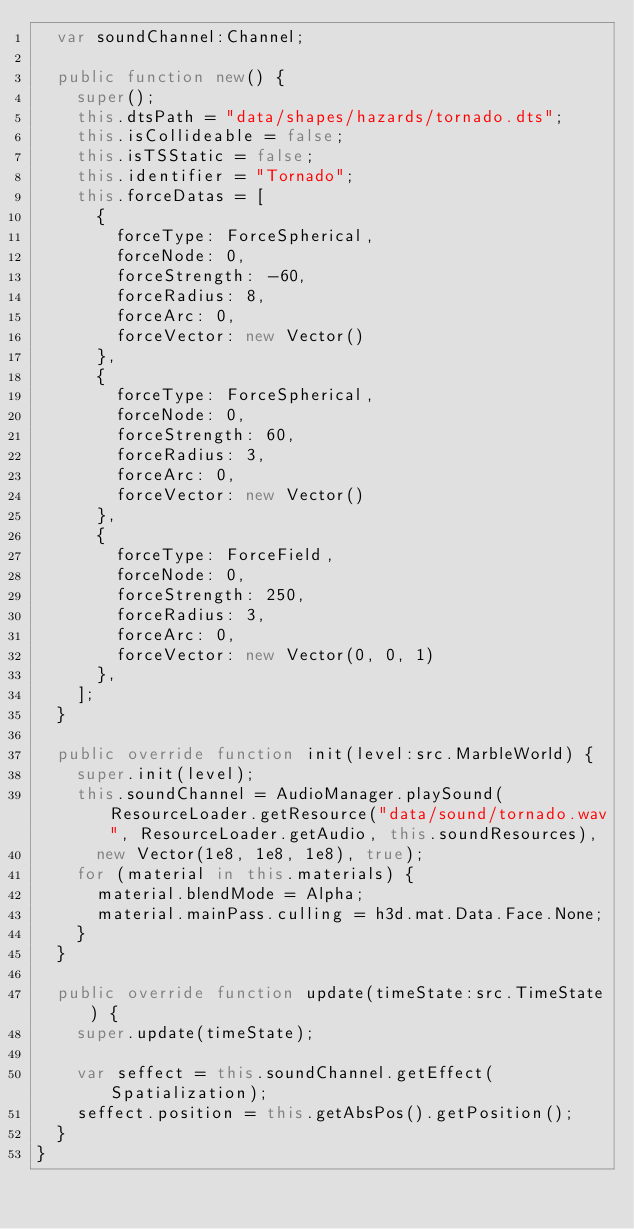Convert code to text. <code><loc_0><loc_0><loc_500><loc_500><_Haxe_>	var soundChannel:Channel;

	public function new() {
		super();
		this.dtsPath = "data/shapes/hazards/tornado.dts";
		this.isCollideable = false;
		this.isTSStatic = false;
		this.identifier = "Tornado";
		this.forceDatas = [
			{
				forceType: ForceSpherical,
				forceNode: 0,
				forceStrength: -60,
				forceRadius: 8,
				forceArc: 0,
				forceVector: new Vector()
			},
			{
				forceType: ForceSpherical,
				forceNode: 0,
				forceStrength: 60,
				forceRadius: 3,
				forceArc: 0,
				forceVector: new Vector()
			},
			{
				forceType: ForceField,
				forceNode: 0,
				forceStrength: 250,
				forceRadius: 3,
				forceArc: 0,
				forceVector: new Vector(0, 0, 1)
			},
		];
	}

	public override function init(level:src.MarbleWorld) {
		super.init(level);
		this.soundChannel = AudioManager.playSound(ResourceLoader.getResource("data/sound/tornado.wav", ResourceLoader.getAudio, this.soundResources),
			new Vector(1e8, 1e8, 1e8), true);
		for (material in this.materials) {
			material.blendMode = Alpha;
			material.mainPass.culling = h3d.mat.Data.Face.None;
		}
	}

	public override function update(timeState:src.TimeState) {
		super.update(timeState);

		var seffect = this.soundChannel.getEffect(Spatialization);
		seffect.position = this.getAbsPos().getPosition();
	}
}
</code> 